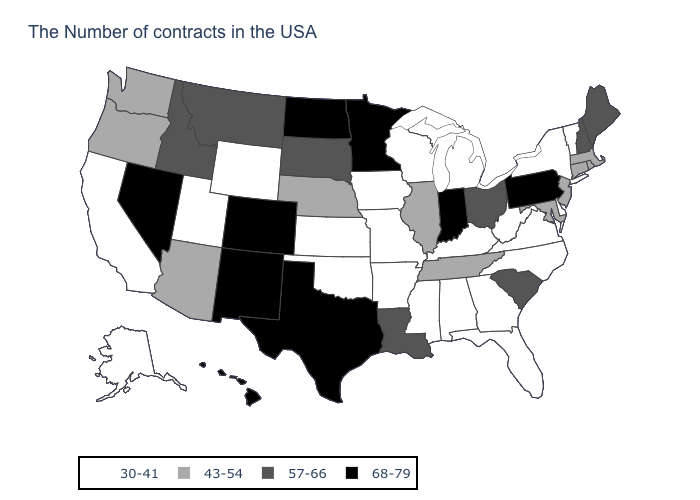What is the value of Kansas?
Quick response, please. 30-41. What is the value of South Dakota?
Answer briefly. 57-66. Is the legend a continuous bar?
Keep it brief. No. What is the highest value in the MidWest ?
Concise answer only. 68-79. Name the states that have a value in the range 43-54?
Write a very short answer. Massachusetts, Rhode Island, Connecticut, New Jersey, Maryland, Tennessee, Illinois, Nebraska, Arizona, Washington, Oregon. What is the value of Nebraska?
Concise answer only. 43-54. What is the value of Alaska?
Short answer required. 30-41. What is the lowest value in states that border South Carolina?
Give a very brief answer. 30-41. What is the lowest value in states that border West Virginia?
Concise answer only. 30-41. Does Maine have the same value as South Carolina?
Quick response, please. Yes. Name the states that have a value in the range 68-79?
Short answer required. Pennsylvania, Indiana, Minnesota, Texas, North Dakota, Colorado, New Mexico, Nevada, Hawaii. What is the value of Alaska?
Quick response, please. 30-41. Does the first symbol in the legend represent the smallest category?
Answer briefly. Yes. Among the states that border New York , which have the highest value?
Concise answer only. Pennsylvania. 